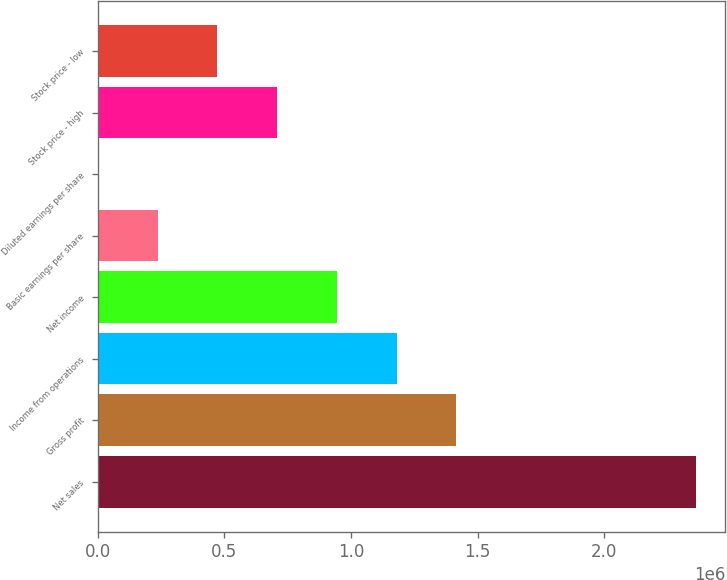Convert chart. <chart><loc_0><loc_0><loc_500><loc_500><bar_chart><fcel>Net sales<fcel>Gross profit<fcel>Income from operations<fcel>Net income<fcel>Basic earnings per share<fcel>Diluted earnings per share<fcel>Stock price - high<fcel>Stock price - low<nl><fcel>2.36049e+06<fcel>1.4163e+06<fcel>1.18025e+06<fcel>944198<fcel>236050<fcel>1.31<fcel>708149<fcel>472100<nl></chart> 